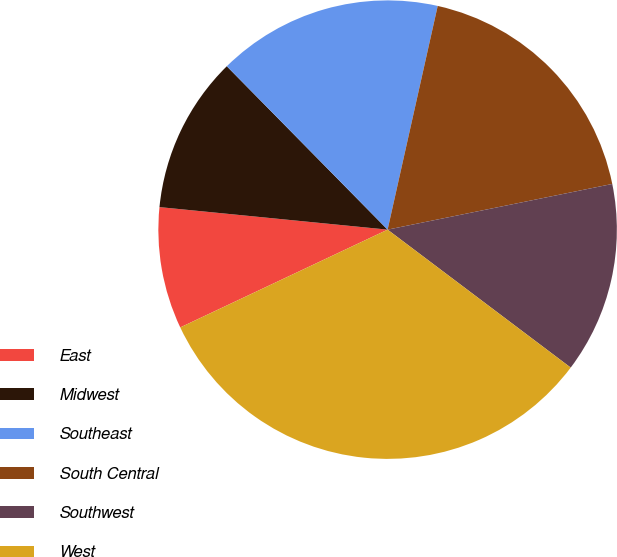<chart> <loc_0><loc_0><loc_500><loc_500><pie_chart><fcel>East<fcel>Midwest<fcel>Southeast<fcel>South Central<fcel>Southwest<fcel>West<nl><fcel>8.58%<fcel>11.06%<fcel>15.88%<fcel>18.3%<fcel>13.47%<fcel>32.71%<nl></chart> 